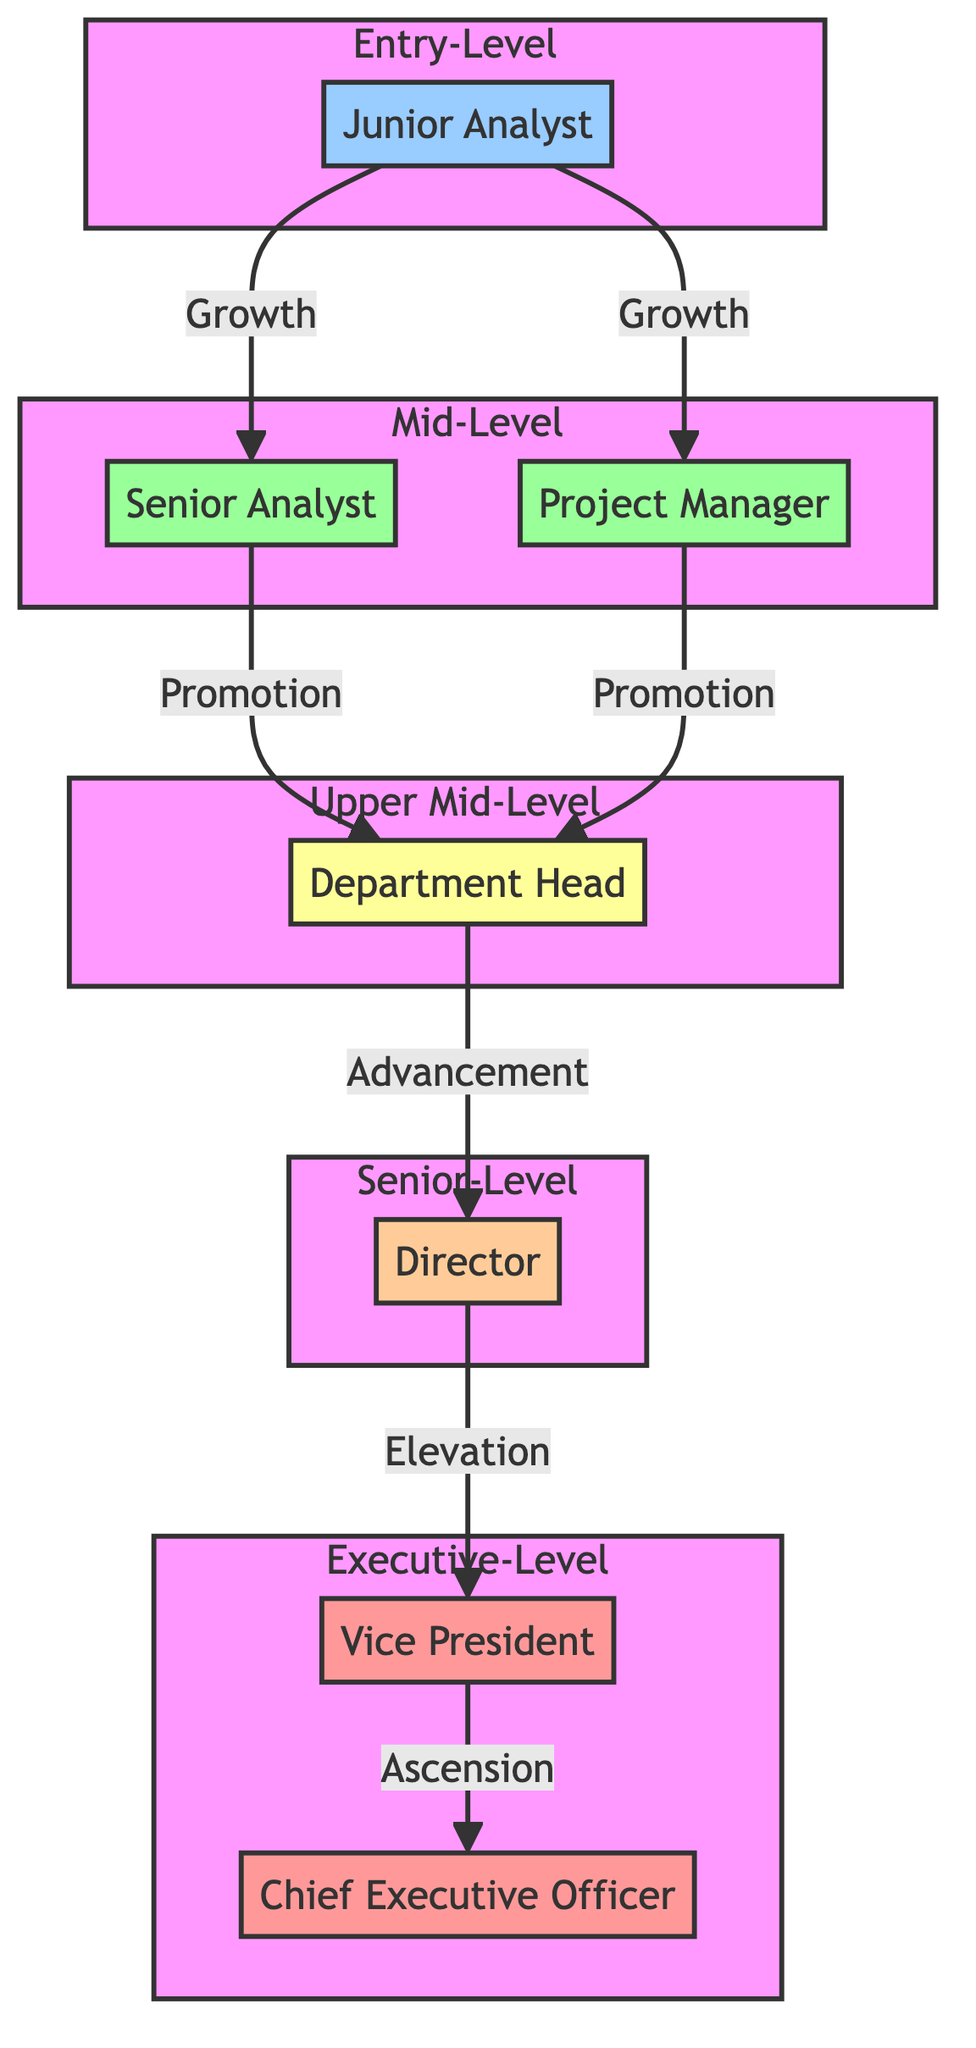What is the title at the Entry-Level? The diagram indicates that the title at the Entry-Level is 'Junior Analyst' since that node represents the starting position in the career growth milestones.
Answer: Junior Analyst How many nodes represent Mid-Level positions? There are two nodes in the diagram that represent Mid-Level positions: 'Senior Analyst' and 'Project Manager.' Counting these two nodes gives the answer.
Answer: 2 What positions are directly above 'Department Head'? The diagram shows that 'Department Head' connects directly to the node above it, which is 'Director.' This indicates that 'Director' is the title directly above 'Department Head.'
Answer: Director What skills are developed in the senior-level role? According to the diagram, the skills developed at the senior-level position of 'Director' include 'Executive decision making,' 'Policy development,' and 'Strategic vision.' Each of these skills is listed under the Director node.
Answer: Executive decision making, Policy development, Strategic vision Which position is the starting point in this career progression? The diagram clearly shows that the starting point in this career progression is 'Junior Analyst,' as this is the first node in the flowchart, indicating the entry-level role.
Answer: Junior Analyst What is the progression path from 'Project Manager' to 'Vice President'? The path from 'Project Manager' to 'Vice President' in the diagram shows that one would first advance to 'Department Head,' then to 'Director,' and finally reach 'Vice President.' This linear flow illustrates the career trajectory.
Answer: Department Head, Director, Vice President How many skills are developed at the Executive-Level? There are six skills developed at the Executive-Level, as indicated under the two nodes for 'Vice President' and 'Chief Executive Officer' when each skill is counted carefully from both positions.
Answer: 6 Which role involves managing project timelines? The diagram indicates that the role responsible for managing project timelines is 'Project Manager,' as this title specifically corresponds to that key responsibility.
Answer: Project Manager What is the last career milestone before reaching the top position? The last career milestone before reaching the top position in the diagram is 'Vice President,' which is one node below the 'Chief Executive Officer,' representing the final step in the career progression.
Answer: Vice President 